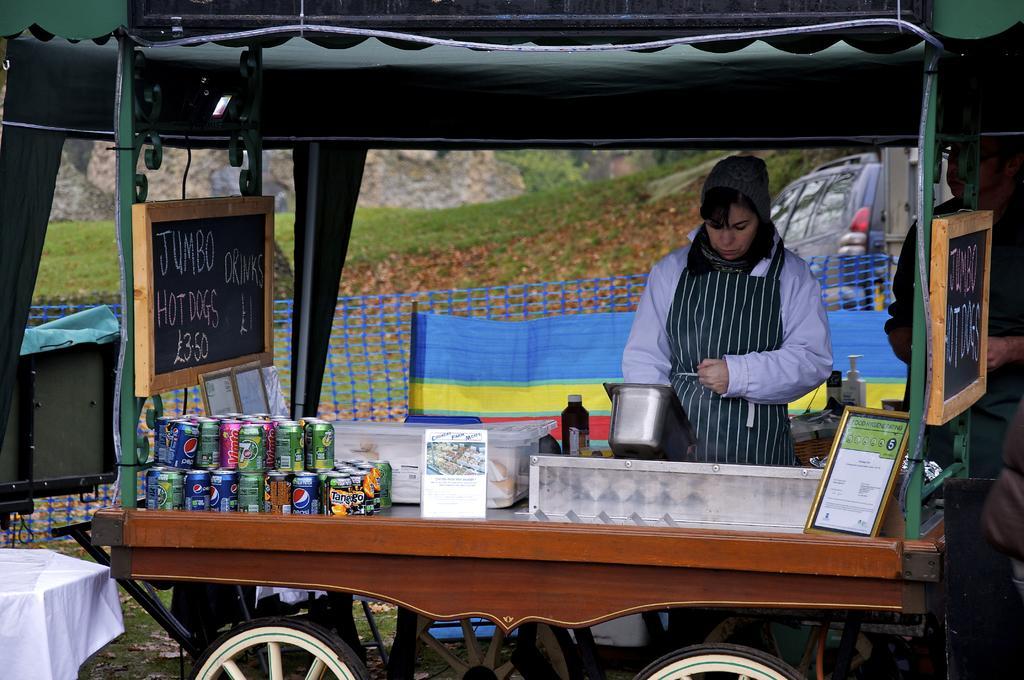In one or two sentences, can you explain what this image depicts? In this image in the front there is a cart and on the cart there are objects which are blue, green and red in colour and there is a board with some text written on it and in the center there is a person standing. In the background there is a fence, there is a car and there's grass on the ground. On the left side there is a table which is covered with a white colour cloth. 